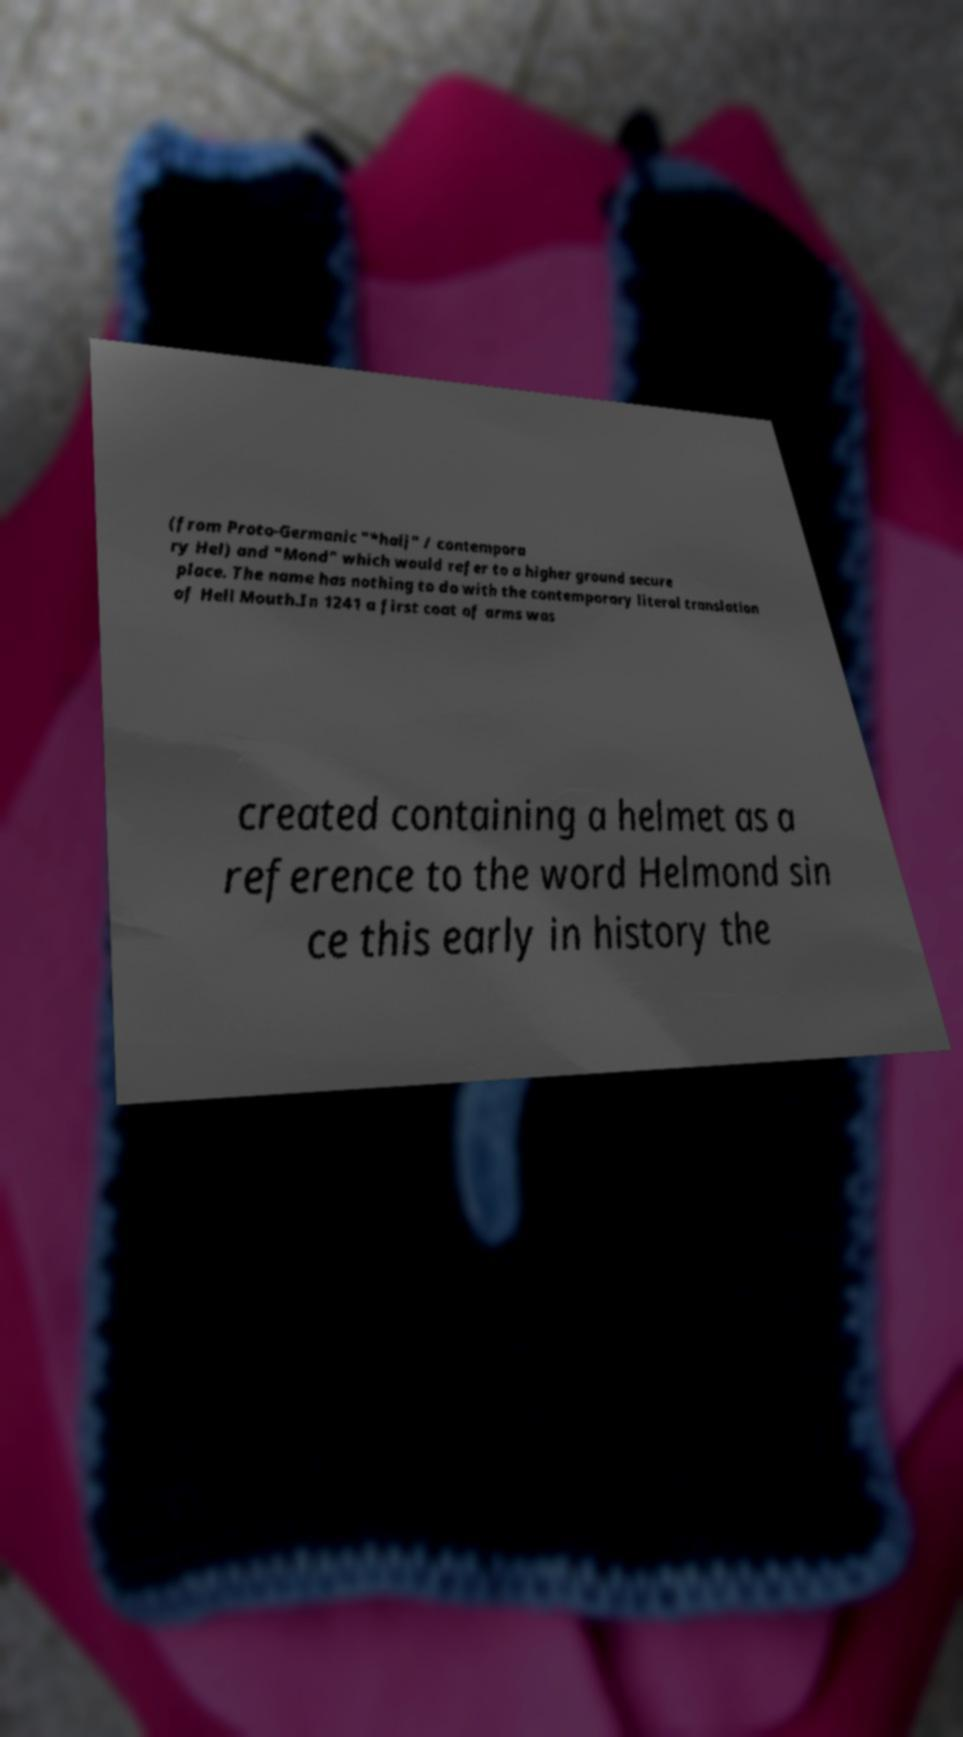Could you assist in decoding the text presented in this image and type it out clearly? (from Proto-Germanic "*halj" / contempora ry Hel) and "Mond" which would refer to a higher ground secure place. The name has nothing to do with the contemporary literal translation of Hell Mouth.In 1241 a first coat of arms was created containing a helmet as a reference to the word Helmond sin ce this early in history the 